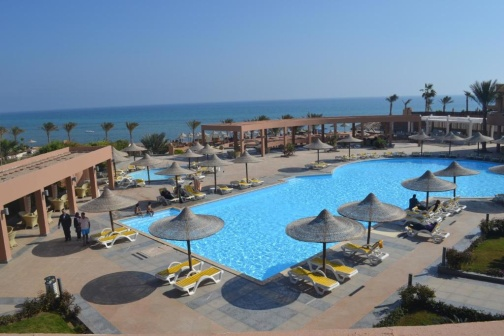Explain the visual content of the image in great detail. The image portrays a luxurious outdoor setting which emanates a sense of relaxation and opulence. At the forefront is a large, attractively shaped swimming pool with clear, bright blue water that sparkles under the sun. Surrounding the pool, numerous yellow-cushioned lounge chairs are neatly arranged, some shaded by thatched umbrellas. The meticulously placed palm trees add a touch of tropical elegance, their green fronds casting dappled shadows on the pool deck. Adjacent to the pool are spacious sunbathing areas with additional seating. To the left, an open-air structure with a flat roof provides additional shaded areas, possibly for dining or lounging. Beyond the immediate pool area, the scene opens up to an extensive view of the ocean, where the seamless horizon blends the deep blue sea with the clear sky. In the background, a distinctive, multi-hued building with a pink exterior and a brown roof, likely a resort or hotel, stands prominently, further enhancing the aura of luxurious leisure. 